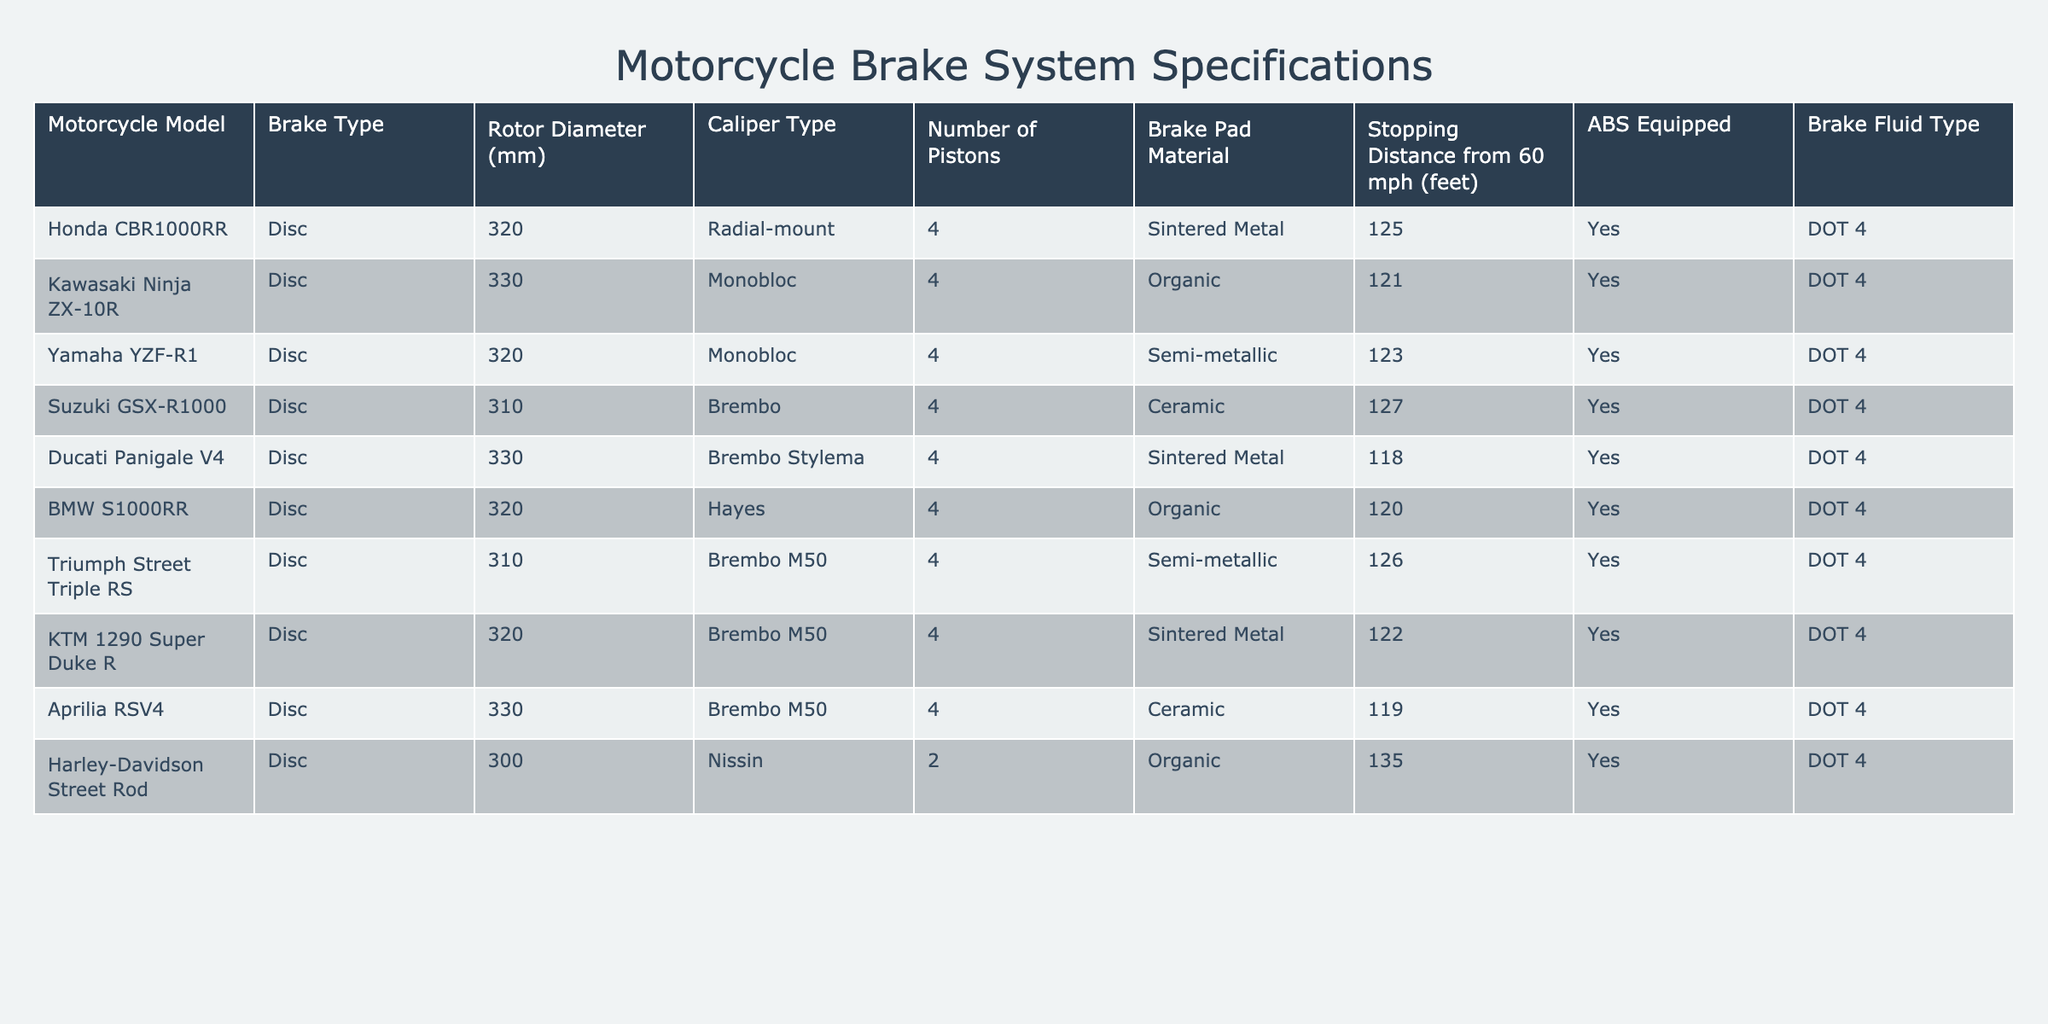What is the stopping distance of the Ducati Panigale V4 from 60 mph? The table lists the stopping distance of the Ducati Panigale V4 as 118 feet.
Answer: 118 feet Which motorcycle has the largest rotor diameter? Looking at the rotor diameter column, the Kawasaki Ninja ZX-10R and Aprilia RSV4 both have a rotor diameter of 330 mm, which is the largest in the list.
Answer: Kawasaki Ninja ZX-10R and Aprilia RSV4 How many motorcycles have a brake fluid type of DOT 4? All motorcycles in the table are listed as equipped with DOT 4 brake fluid. There are 10 motorcycles, so the answer is 10.
Answer: 10 Is the Harley-Davidson Street Rod equipped with ABS? The table indicates that the Harley-Davidson Street Rod has "Yes" listed under the ABS Equipped column.
Answer: Yes What is the average stopping distance of the motorcycles equipped with ABS? To find the average stopping distance of motorcycles with ABS: (125 + 121 + 123 + 127 + 118 + 120 + 126 + 122 + 119 + 135) = 1296 feet. There are 10 models, so the average is 1296/10 = 129.6 feet.
Answer: 129.6 feet Which motorcycle has the highest number of pistons? All motorcycles listed in the table have 4 pistons except for the Harley-Davidson Street Rod, which has only 2. Thus, the highest number of pistons is 4.
Answer: 4 What is the stopping distance difference between the Suzuki GSX-R1000 and the Yamaha YZF-R1? The stopping distance of the Suzuki GSX-R1000 is 127 feet and for the Yamaha YZF-R1 it is 123 feet. The difference is 127 - 123 = 4 feet.
Answer: 4 feet Which brake pad material is used in the BMW S1000RR? The table indicates that the BMW S1000RR uses Organic brake pad material.
Answer: Organic How many motorcycles have a ceramic brake pad material and are equipped with ABS? The motorcycles that have ceramic brake pad material are the Suzuki GSX-R1000 and Aprilia RSV4, both of which are equipped with ABS. Therefore, there are 2 motorcycles.
Answer: 2 Which motorcycle has the shortest stopping distance, and what is that distance? The table shows that the Ducati Panigale V4 has the shortest stopping distance at 118 feet.
Answer: Ducati Panigale V4, 118 feet 